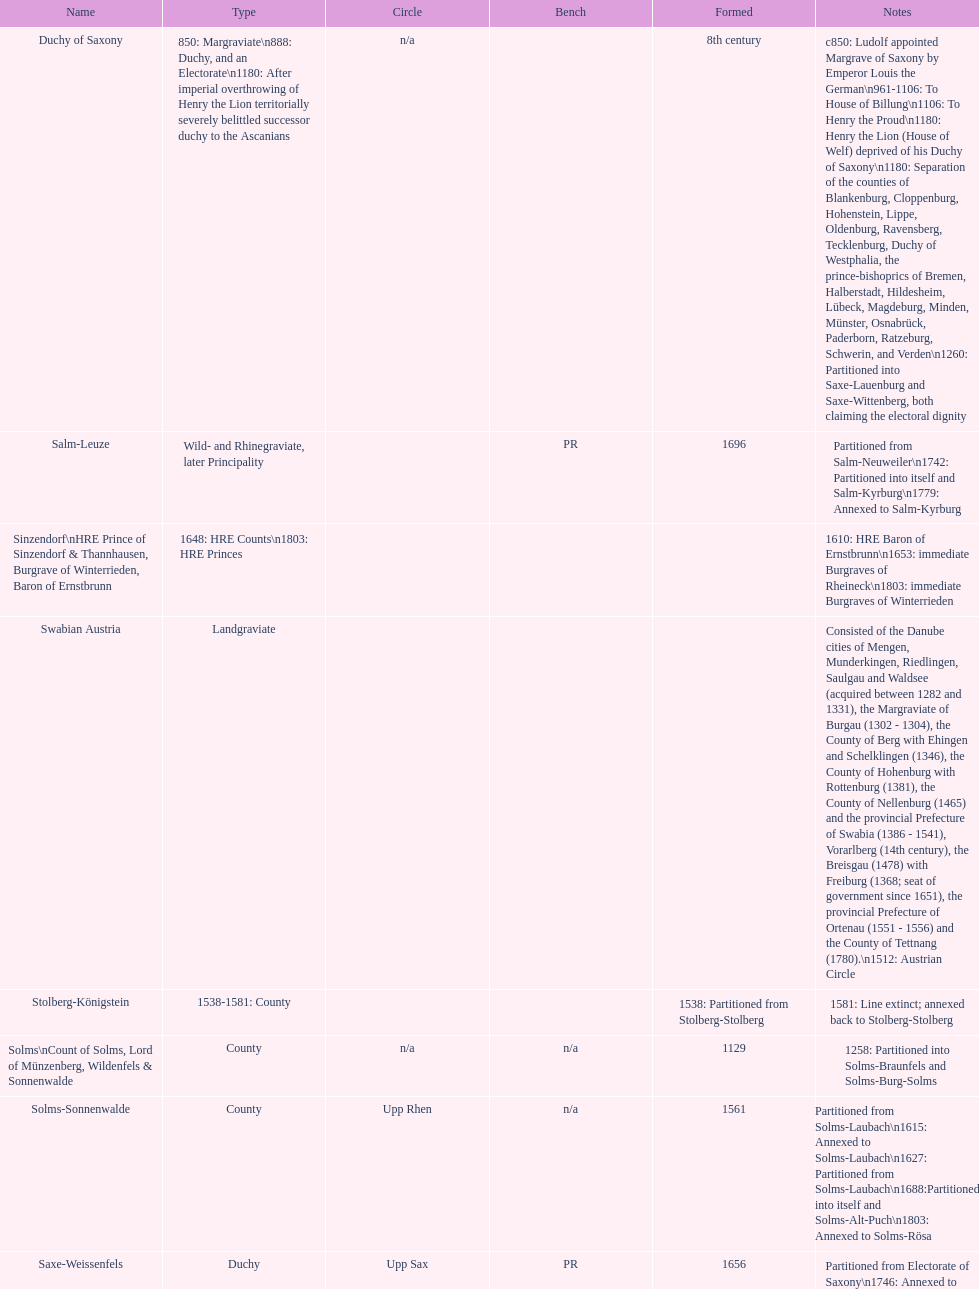What is the status above "sagan"? Saarwerden and Lahr. 